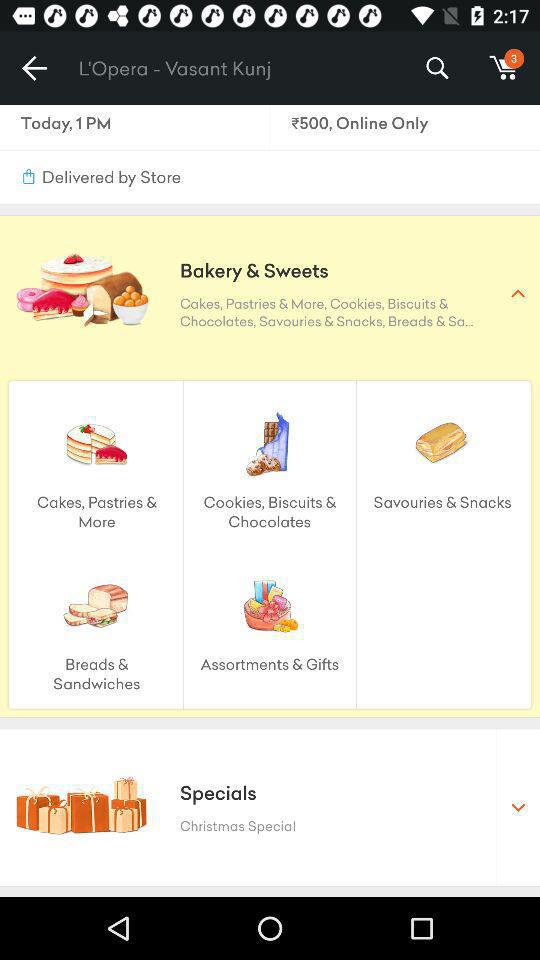What is the delivery time displayed on the screen? The displayed time is 1 PM. 